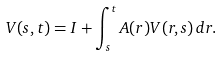<formula> <loc_0><loc_0><loc_500><loc_500>V ( s , t ) = I + \int _ { s } ^ { t } A ( r ) V ( r , s ) \, d r .</formula> 